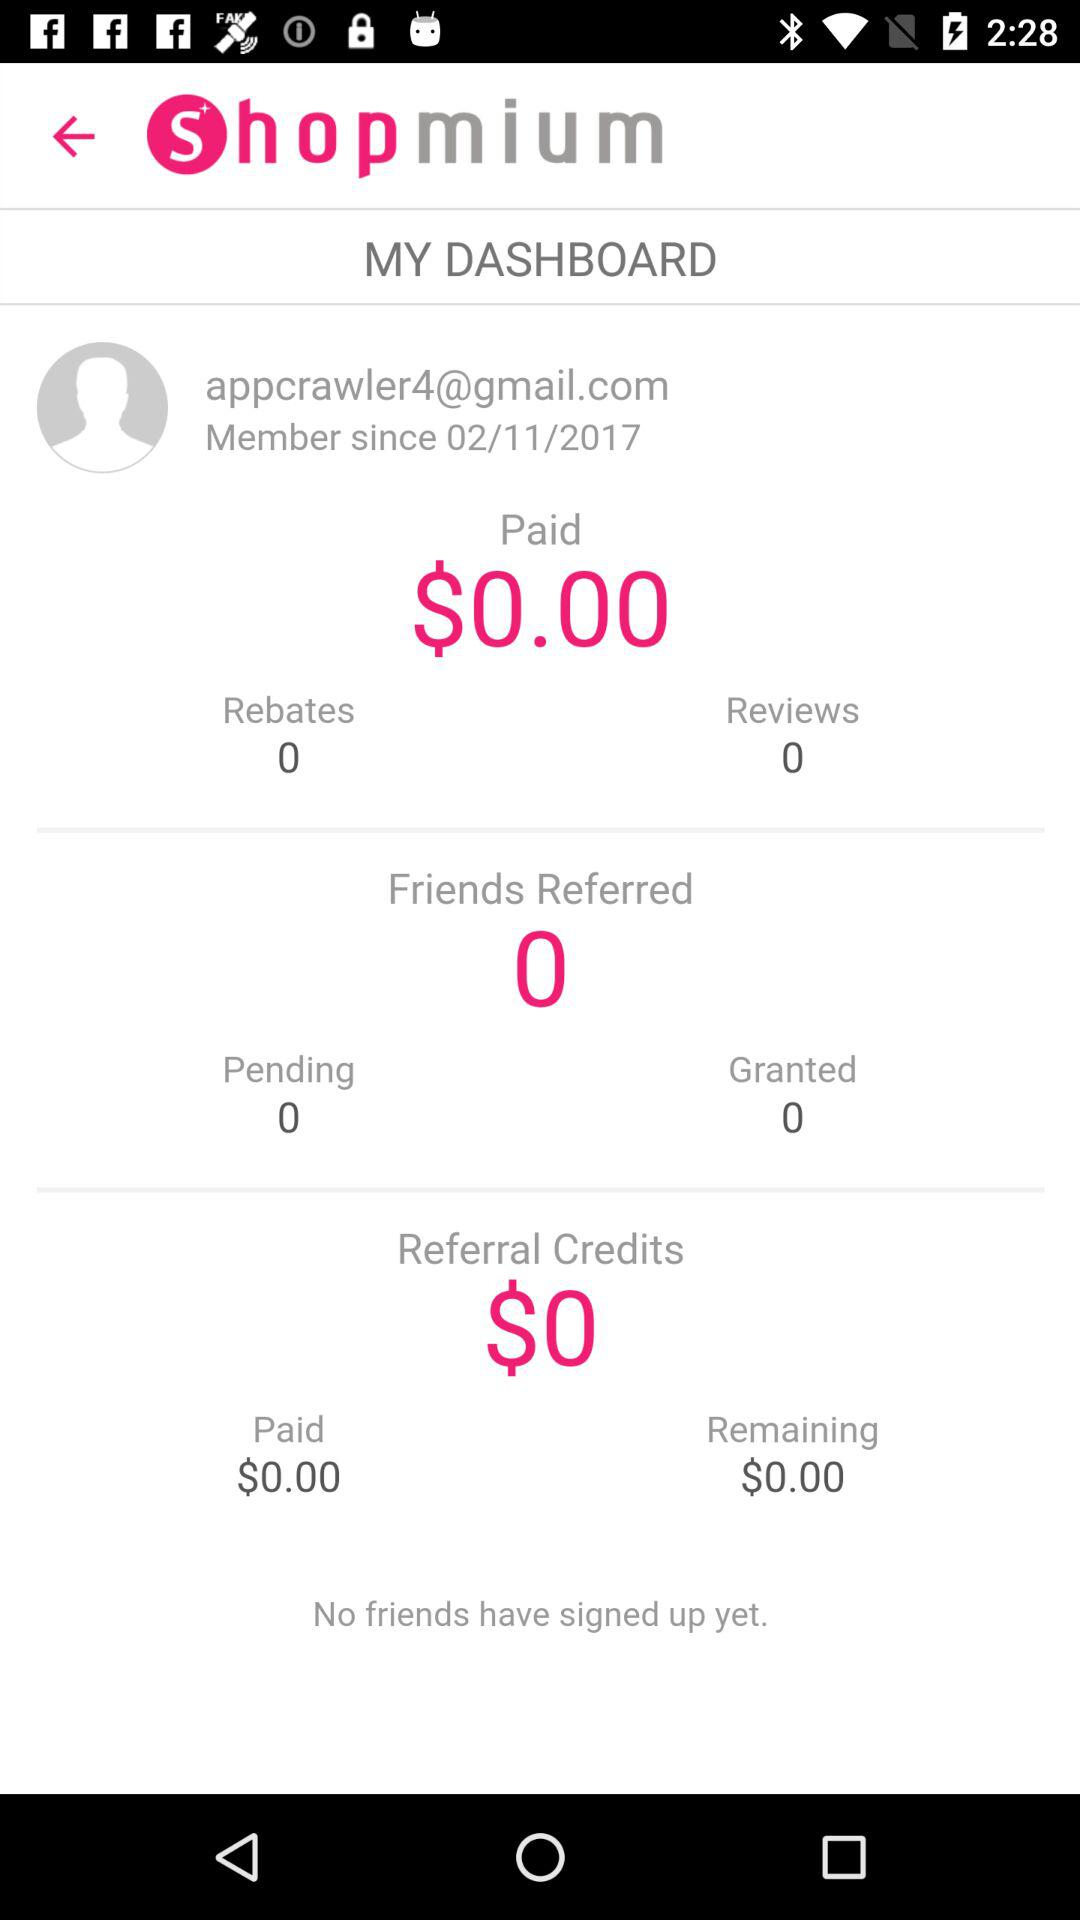How much money have I earned in total?
Answer the question using a single word or phrase. $0.00 